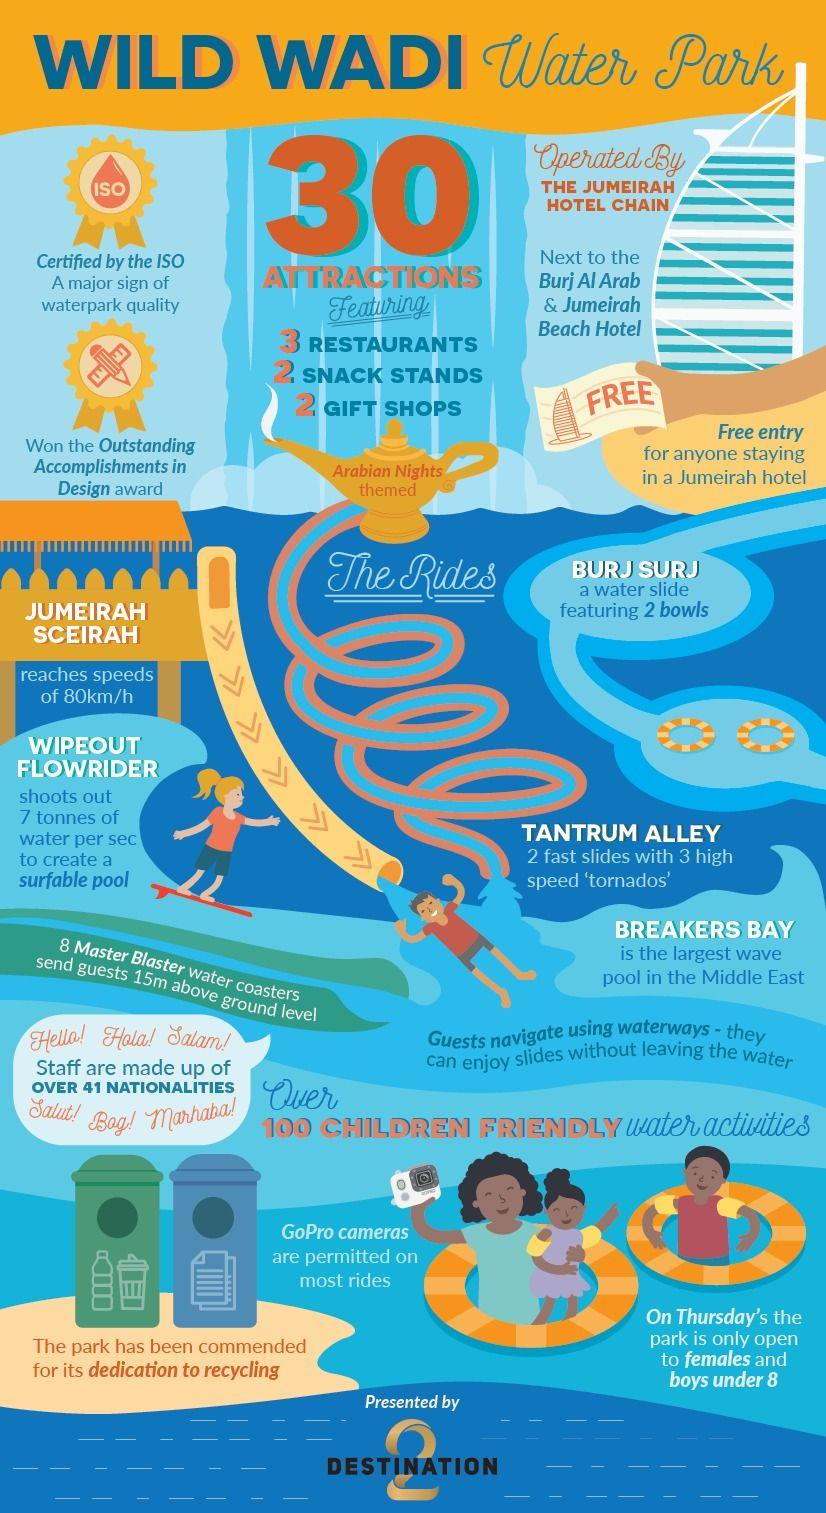Outline some significant characteristics in this image. The largest wave pool in the Middle East can be found at Wild Wadi Water Park. The lamp displays an Arabian Nights-themed inscription. Marhaba in English translates to 'Hello.' Wipeout Flowrider is the factor that creates a surfable pool. The ride with two bowls is called "Burj Surj. 